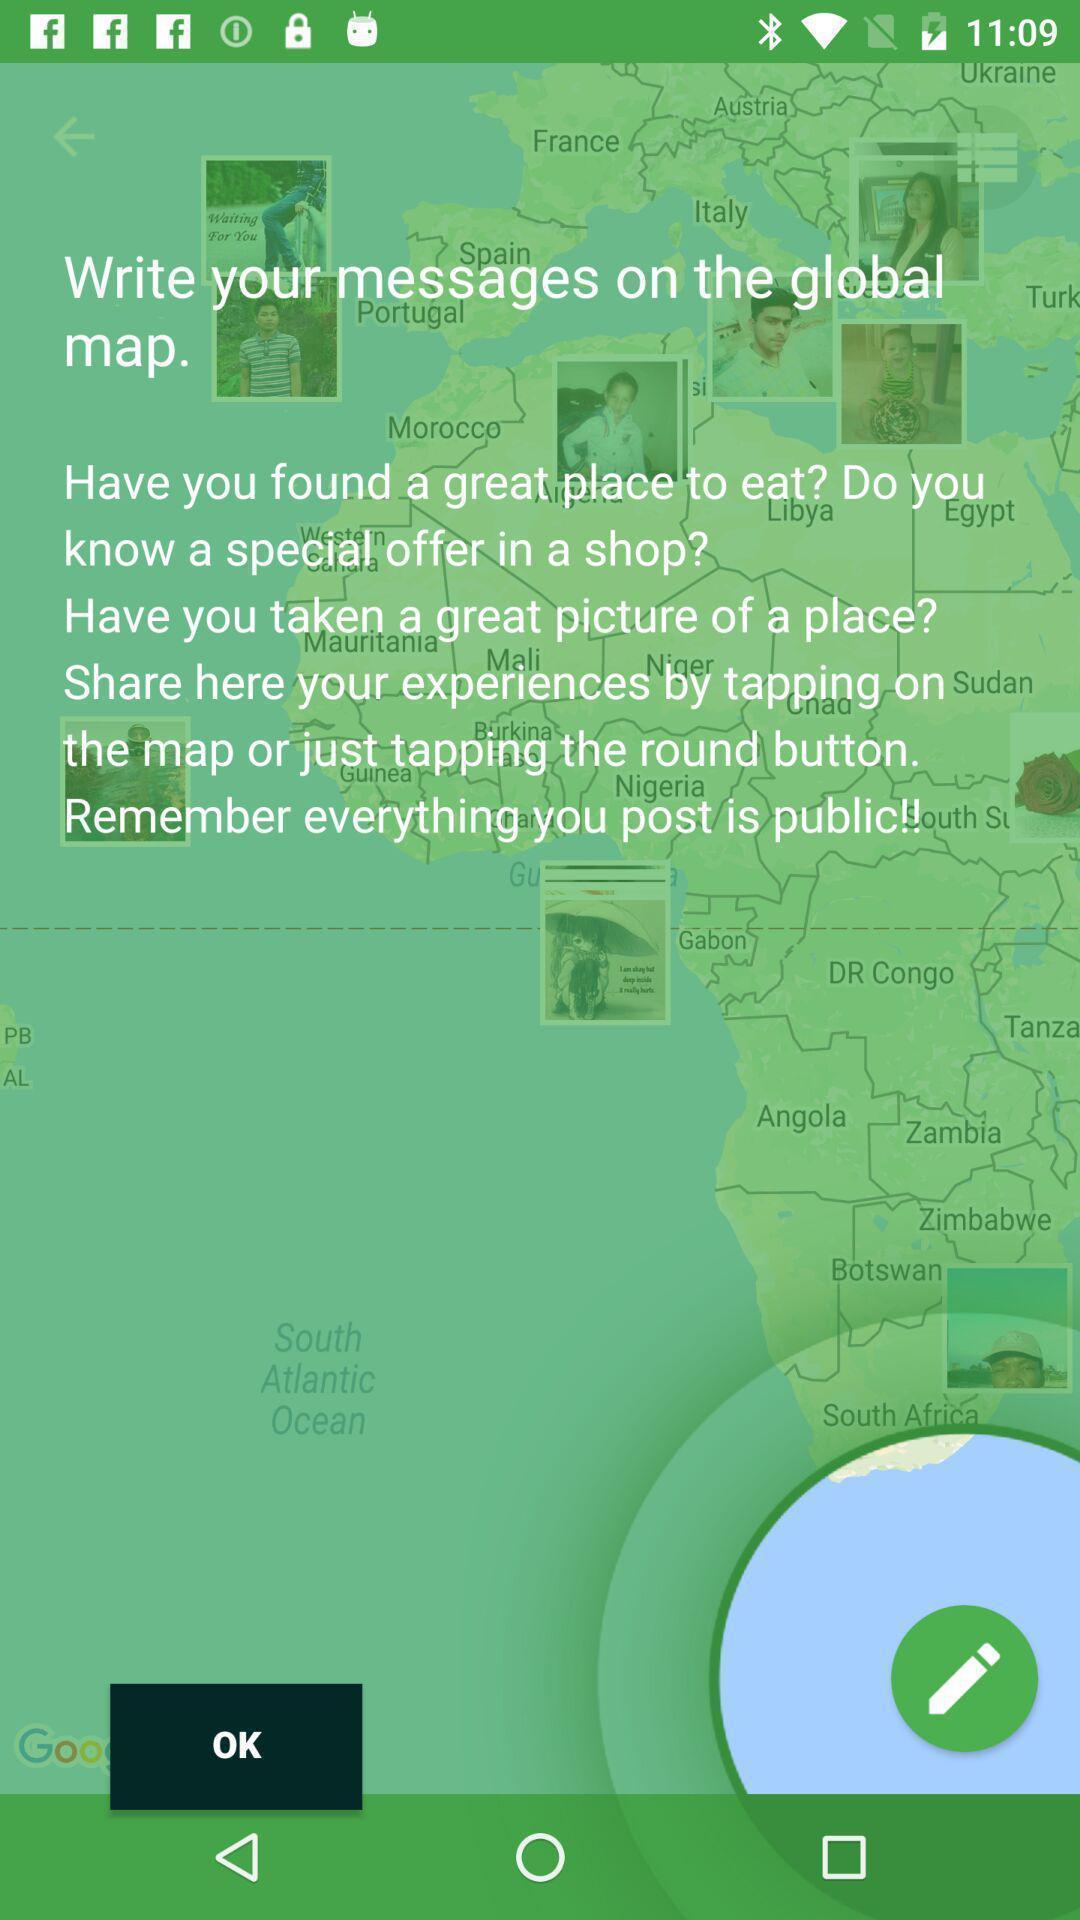What can you discern from this picture? Screen displaying demo instructions to access an application. 